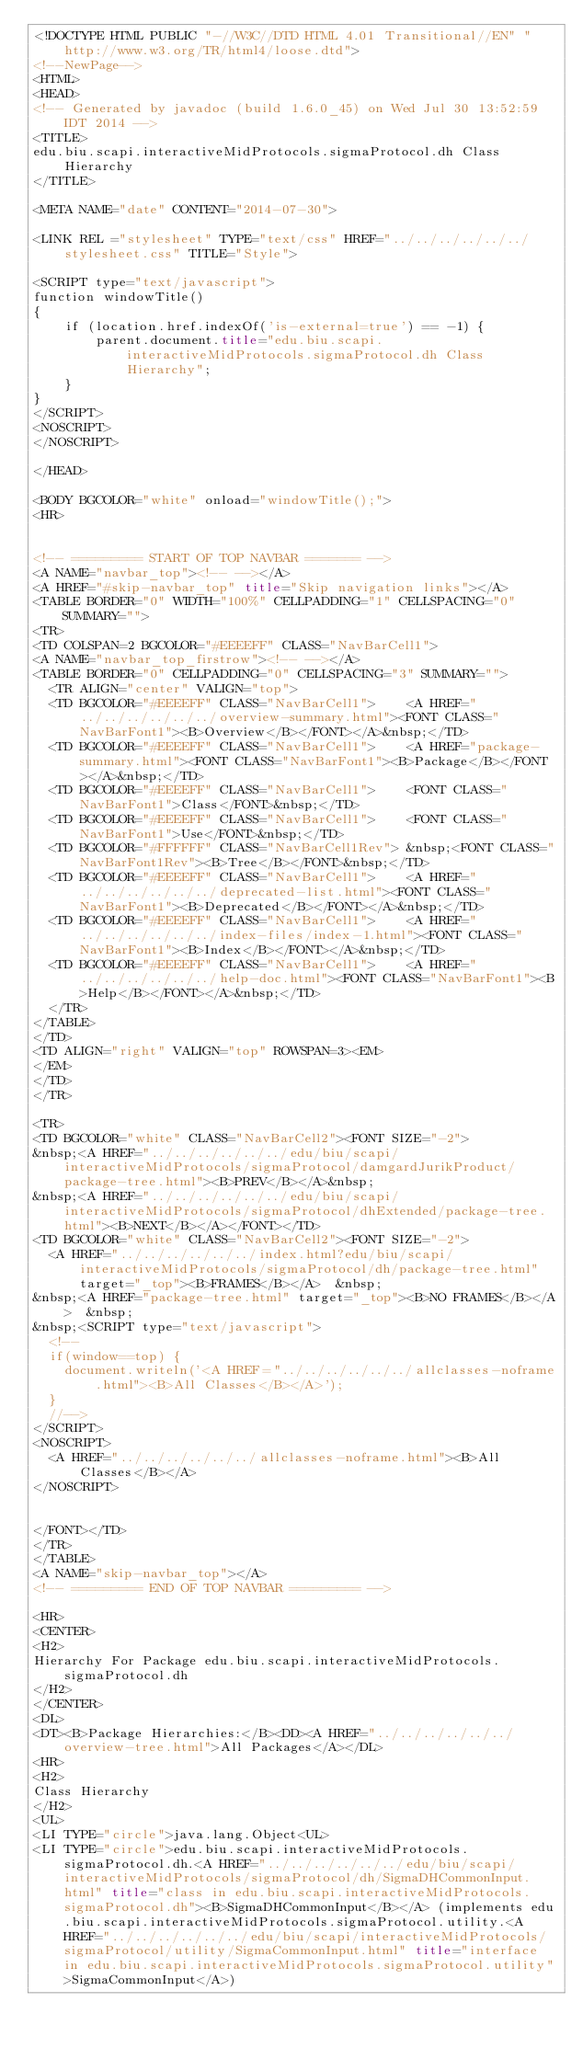<code> <loc_0><loc_0><loc_500><loc_500><_HTML_><!DOCTYPE HTML PUBLIC "-//W3C//DTD HTML 4.01 Transitional//EN" "http://www.w3.org/TR/html4/loose.dtd">
<!--NewPage-->
<HTML>
<HEAD>
<!-- Generated by javadoc (build 1.6.0_45) on Wed Jul 30 13:52:59 IDT 2014 -->
<TITLE>
edu.biu.scapi.interactiveMidProtocols.sigmaProtocol.dh Class Hierarchy
</TITLE>

<META NAME="date" CONTENT="2014-07-30">

<LINK REL ="stylesheet" TYPE="text/css" HREF="../../../../../../stylesheet.css" TITLE="Style">

<SCRIPT type="text/javascript">
function windowTitle()
{
    if (location.href.indexOf('is-external=true') == -1) {
        parent.document.title="edu.biu.scapi.interactiveMidProtocols.sigmaProtocol.dh Class Hierarchy";
    }
}
</SCRIPT>
<NOSCRIPT>
</NOSCRIPT>

</HEAD>

<BODY BGCOLOR="white" onload="windowTitle();">
<HR>


<!-- ========= START OF TOP NAVBAR ======= -->
<A NAME="navbar_top"><!-- --></A>
<A HREF="#skip-navbar_top" title="Skip navigation links"></A>
<TABLE BORDER="0" WIDTH="100%" CELLPADDING="1" CELLSPACING="0" SUMMARY="">
<TR>
<TD COLSPAN=2 BGCOLOR="#EEEEFF" CLASS="NavBarCell1">
<A NAME="navbar_top_firstrow"><!-- --></A>
<TABLE BORDER="0" CELLPADDING="0" CELLSPACING="3" SUMMARY="">
  <TR ALIGN="center" VALIGN="top">
  <TD BGCOLOR="#EEEEFF" CLASS="NavBarCell1">    <A HREF="../../../../../../overview-summary.html"><FONT CLASS="NavBarFont1"><B>Overview</B></FONT></A>&nbsp;</TD>
  <TD BGCOLOR="#EEEEFF" CLASS="NavBarCell1">    <A HREF="package-summary.html"><FONT CLASS="NavBarFont1"><B>Package</B></FONT></A>&nbsp;</TD>
  <TD BGCOLOR="#EEEEFF" CLASS="NavBarCell1">    <FONT CLASS="NavBarFont1">Class</FONT>&nbsp;</TD>
  <TD BGCOLOR="#EEEEFF" CLASS="NavBarCell1">    <FONT CLASS="NavBarFont1">Use</FONT>&nbsp;</TD>
  <TD BGCOLOR="#FFFFFF" CLASS="NavBarCell1Rev"> &nbsp;<FONT CLASS="NavBarFont1Rev"><B>Tree</B></FONT>&nbsp;</TD>
  <TD BGCOLOR="#EEEEFF" CLASS="NavBarCell1">    <A HREF="../../../../../../deprecated-list.html"><FONT CLASS="NavBarFont1"><B>Deprecated</B></FONT></A>&nbsp;</TD>
  <TD BGCOLOR="#EEEEFF" CLASS="NavBarCell1">    <A HREF="../../../../../../index-files/index-1.html"><FONT CLASS="NavBarFont1"><B>Index</B></FONT></A>&nbsp;</TD>
  <TD BGCOLOR="#EEEEFF" CLASS="NavBarCell1">    <A HREF="../../../../../../help-doc.html"><FONT CLASS="NavBarFont1"><B>Help</B></FONT></A>&nbsp;</TD>
  </TR>
</TABLE>
</TD>
<TD ALIGN="right" VALIGN="top" ROWSPAN=3><EM>
</EM>
</TD>
</TR>

<TR>
<TD BGCOLOR="white" CLASS="NavBarCell2"><FONT SIZE="-2">
&nbsp;<A HREF="../../../../../../edu/biu/scapi/interactiveMidProtocols/sigmaProtocol/damgardJurikProduct/package-tree.html"><B>PREV</B></A>&nbsp;
&nbsp;<A HREF="../../../../../../edu/biu/scapi/interactiveMidProtocols/sigmaProtocol/dhExtended/package-tree.html"><B>NEXT</B></A></FONT></TD>
<TD BGCOLOR="white" CLASS="NavBarCell2"><FONT SIZE="-2">
  <A HREF="../../../../../../index.html?edu/biu/scapi/interactiveMidProtocols/sigmaProtocol/dh/package-tree.html" target="_top"><B>FRAMES</B></A>  &nbsp;
&nbsp;<A HREF="package-tree.html" target="_top"><B>NO FRAMES</B></A>  &nbsp;
&nbsp;<SCRIPT type="text/javascript">
  <!--
  if(window==top) {
    document.writeln('<A HREF="../../../../../../allclasses-noframe.html"><B>All Classes</B></A>');
  }
  //-->
</SCRIPT>
<NOSCRIPT>
  <A HREF="../../../../../../allclasses-noframe.html"><B>All Classes</B></A>
</NOSCRIPT>


</FONT></TD>
</TR>
</TABLE>
<A NAME="skip-navbar_top"></A>
<!-- ========= END OF TOP NAVBAR ========= -->

<HR>
<CENTER>
<H2>
Hierarchy For Package edu.biu.scapi.interactiveMidProtocols.sigmaProtocol.dh
</H2>
</CENTER>
<DL>
<DT><B>Package Hierarchies:</B><DD><A HREF="../../../../../../overview-tree.html">All Packages</A></DL>
<HR>
<H2>
Class Hierarchy
</H2>
<UL>
<LI TYPE="circle">java.lang.Object<UL>
<LI TYPE="circle">edu.biu.scapi.interactiveMidProtocols.sigmaProtocol.dh.<A HREF="../../../../../../edu/biu/scapi/interactiveMidProtocols/sigmaProtocol/dh/SigmaDHCommonInput.html" title="class in edu.biu.scapi.interactiveMidProtocols.sigmaProtocol.dh"><B>SigmaDHCommonInput</B></A> (implements edu.biu.scapi.interactiveMidProtocols.sigmaProtocol.utility.<A HREF="../../../../../../edu/biu/scapi/interactiveMidProtocols/sigmaProtocol/utility/SigmaCommonInput.html" title="interface in edu.biu.scapi.interactiveMidProtocols.sigmaProtocol.utility">SigmaCommonInput</A>)</code> 